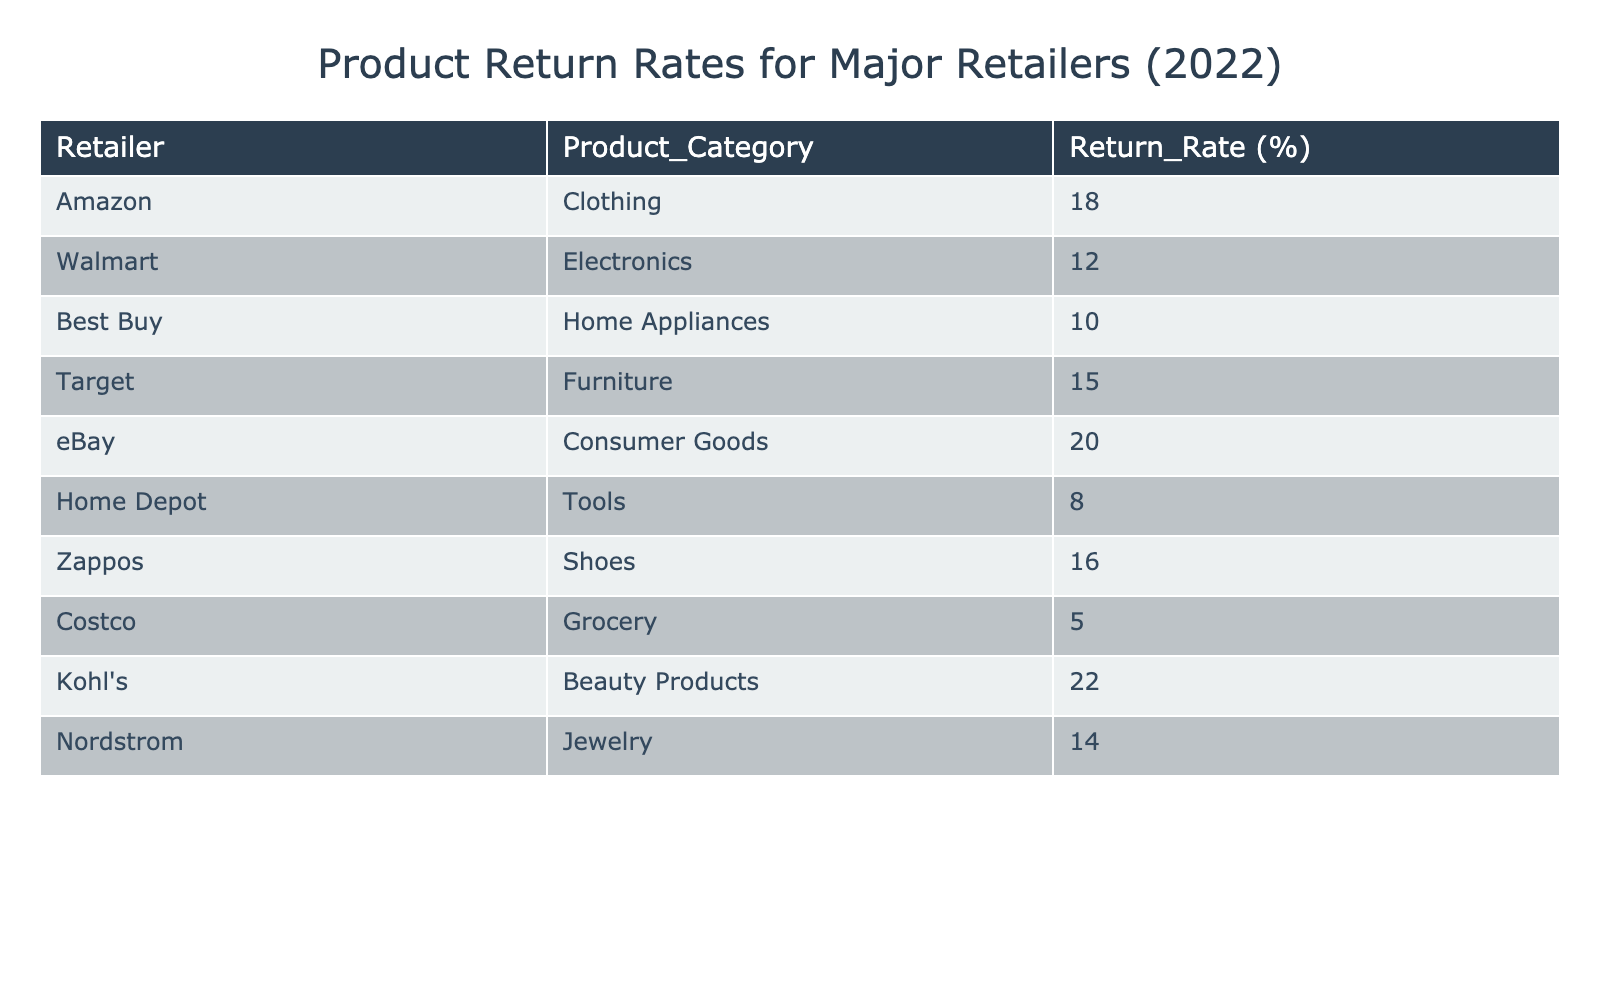What is the return rate for Amazon in the clothing category? According to the table, Amazon has a return rate of 18% specifically for clothing.
Answer: 18% Which retailer has the highest return rate and what is that rate? Kohl's has the highest return rate at 22%.
Answer: 22% What is the average return rate of the electronics category from Walmart and the home appliances category from Best Buy? Walmart has a return rate of 12% in electronics and Best Buy has 10% in home appliances. The average is (12 + 10) / 2 = 11%.
Answer: 11% Is the return rate for shoes higher than 15%? Zappos has a return rate of 16% for shoes, which is indeed higher than 15%.
Answer: Yes How much higher is the return rate of eBay's consumer goods compared to Costco's grocery return rate? eBay has a return rate of 20% for consumer goods and Costco has 5% for grocery. The difference is 20 - 5 = 15%.
Answer: 15% What is the total return rate for furniture products from Target and electronics from Walmart combined? Target has a return rate of 15% for furniture and Walmart has 12% for electronics. The total is 15 + 12 = 27%.
Answer: 27% Which retailer has a lower return rate: Home Depot or Nordstrom? Home Depot has a return rate of 8% for tools, while Nordstrom has 14% for jewelry. Since 8% is less than 14%, Home Depot has the lower return rate.
Answer: Home Depot Now, what would be the median return rate if we list all the provided rates in ascending order? The return rates in ascending order are: 5, 8, 10, 12, 14, 15, 16, 18, 20, 22. The median, being the average of the 5th and 6th values, is (14 + 15) / 2 = 14.5%.
Answer: 14.5% 